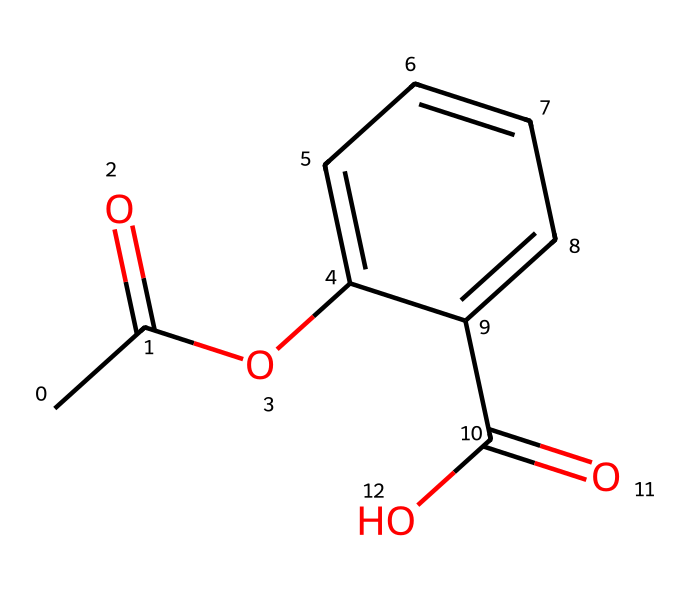What is the molecular formula for the aspirin molecule? To determine the molecular formula, we can count the number of each type of atom in the structure. The given SMILES shows 9 carbon atoms, 8 hydrogen atoms, and 4 oxygen atoms. Therefore, the molecular formula corresponds to C9H8O4.
Answer: C9H8O4 How many rings are present in the aspirin structure? The visual representation indicates one cyclic structure, which is the benzene ring present in the compound. This means there is a single ring in the aspirin molecule's chemical structure.
Answer: 1 What types of functional groups are present in this molecule? By analyzing the structure, we observe multiple functional groups: an acetyl group (R–CO–CH3), a carboxylic acid (–COOH), and an ester group (–COO–). These groups contribute to the chemical's properties and functionalities.
Answer: ester, acetyl, carboxylic acid What is the expected pH effect of dissolving aspirin in water? Aspirin contains a carboxylic acid group, which can donate a proton (H+) in solution, leading to an acidic environment. Therefore, when dissolved in water, it is expected to lower the pH.
Answer: acidic What is the primary use of aspirin based on its chemical structure? Aspirin is commonly known for its role as a nonsteroidal anti-inflammatory drug (NSAID), which is consistent with the presence of the acetyl and carboxylic acid functional groups that are known to inhibit cyclooxygenase enzymes.
Answer: pain relief 